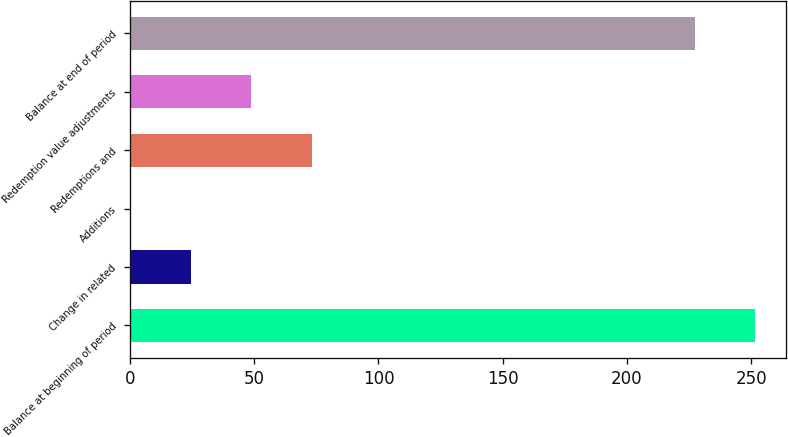Convert chart to OTSL. <chart><loc_0><loc_0><loc_500><loc_500><bar_chart><fcel>Balance at beginning of period<fcel>Change in related<fcel>Additions<fcel>Redemptions and<fcel>Redemption value adjustments<fcel>Balance at end of period<nl><fcel>251.52<fcel>24.5<fcel>0.18<fcel>73.14<fcel>48.82<fcel>227.2<nl></chart> 